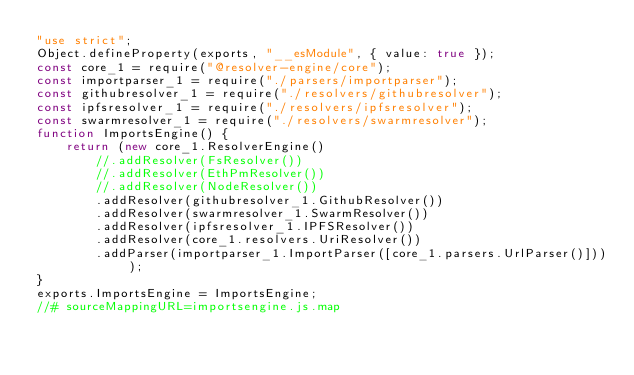Convert code to text. <code><loc_0><loc_0><loc_500><loc_500><_JavaScript_>"use strict";
Object.defineProperty(exports, "__esModule", { value: true });
const core_1 = require("@resolver-engine/core");
const importparser_1 = require("./parsers/importparser");
const githubresolver_1 = require("./resolvers/githubresolver");
const ipfsresolver_1 = require("./resolvers/ipfsresolver");
const swarmresolver_1 = require("./resolvers/swarmresolver");
function ImportsEngine() {
    return (new core_1.ResolverEngine()
        //.addResolver(FsResolver())
        //.addResolver(EthPmResolver())
        //.addResolver(NodeResolver())
        .addResolver(githubresolver_1.GithubResolver())
        .addResolver(swarmresolver_1.SwarmResolver())
        .addResolver(ipfsresolver_1.IPFSResolver())
        .addResolver(core_1.resolvers.UriResolver())
        .addParser(importparser_1.ImportParser([core_1.parsers.UrlParser()])));
}
exports.ImportsEngine = ImportsEngine;
//# sourceMappingURL=importsengine.js.map</code> 